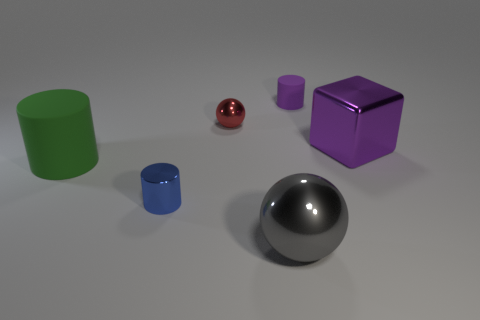Subtract all matte cylinders. How many cylinders are left? 1 Add 4 purple blocks. How many objects exist? 10 Subtract 1 cylinders. How many cylinders are left? 2 Subtract all cyan cylinders. Subtract all cyan spheres. How many cylinders are left? 3 Subtract all balls. How many objects are left? 4 Subtract all big green matte objects. Subtract all metal things. How many objects are left? 1 Add 4 big purple blocks. How many big purple blocks are left? 5 Add 1 small purple rubber things. How many small purple rubber things exist? 2 Subtract 0 yellow cylinders. How many objects are left? 6 